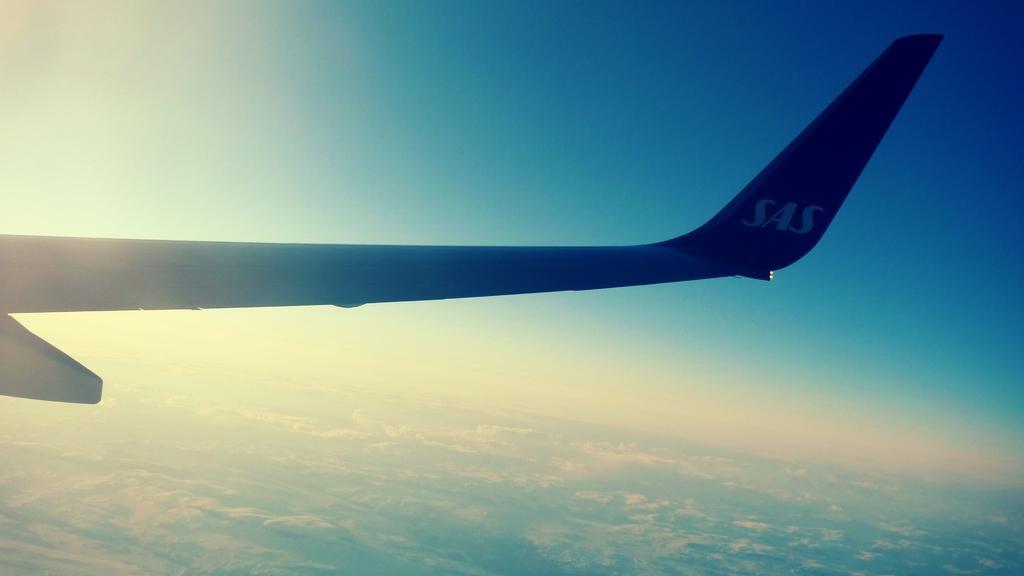Please provide a concise description of this image. In this picture we can see an airplane flying in the sky and below this airplane we can see the ground. 